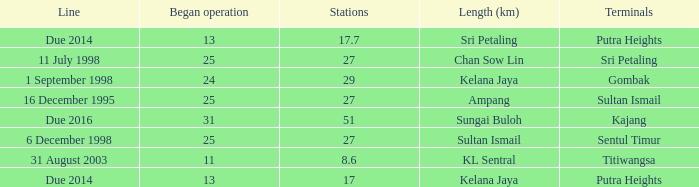I'm looking to parse the entire table for insights. Could you assist me with that? {'header': ['Line', 'Began operation', 'Stations', 'Length (km)', 'Terminals'], 'rows': [['Due 2014', '13', '17.7', 'Sri Petaling', 'Putra Heights'], ['11 July 1998', '25', '27', 'Chan Sow Lin', 'Sri Petaling'], ['1 September 1998', '24', '29', 'Kelana Jaya', 'Gombak'], ['16 December 1995', '25', '27', 'Ampang', 'Sultan Ismail'], ['Due 2016', '31', '51', 'Sungai Buloh', 'Kajang'], ['6 December 1998', '25', '27', 'Sultan Ismail', 'Sentul Timur'], ['31 August 2003', '11', '8.6', 'KL Sentral', 'Titiwangsa'], ['Due 2014', '13', '17', 'Kelana Jaya', 'Putra Heights']]} What is the average operation beginning with a length of ampang and over 27 stations? None. 